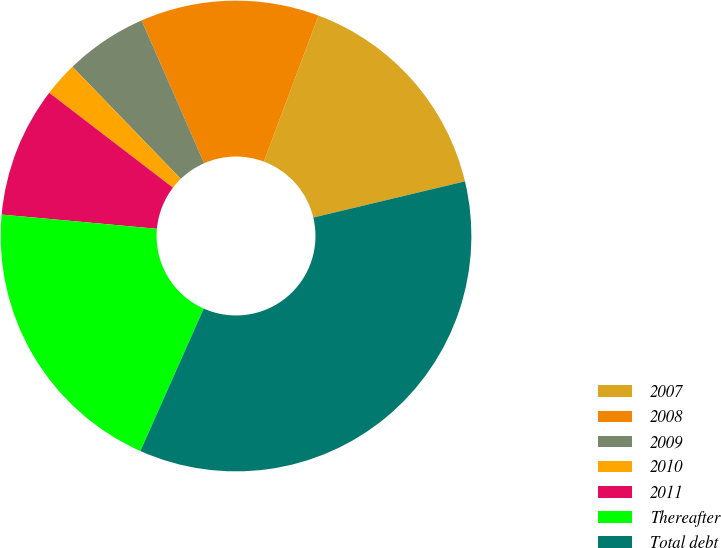Convert chart to OTSL. <chart><loc_0><loc_0><loc_500><loc_500><pie_chart><fcel>2007<fcel>2008<fcel>2009<fcel>2010<fcel>2011<fcel>Thereafter<fcel>Total debt<nl><fcel>15.57%<fcel>12.27%<fcel>5.66%<fcel>2.36%<fcel>8.96%<fcel>19.79%<fcel>35.39%<nl></chart> 